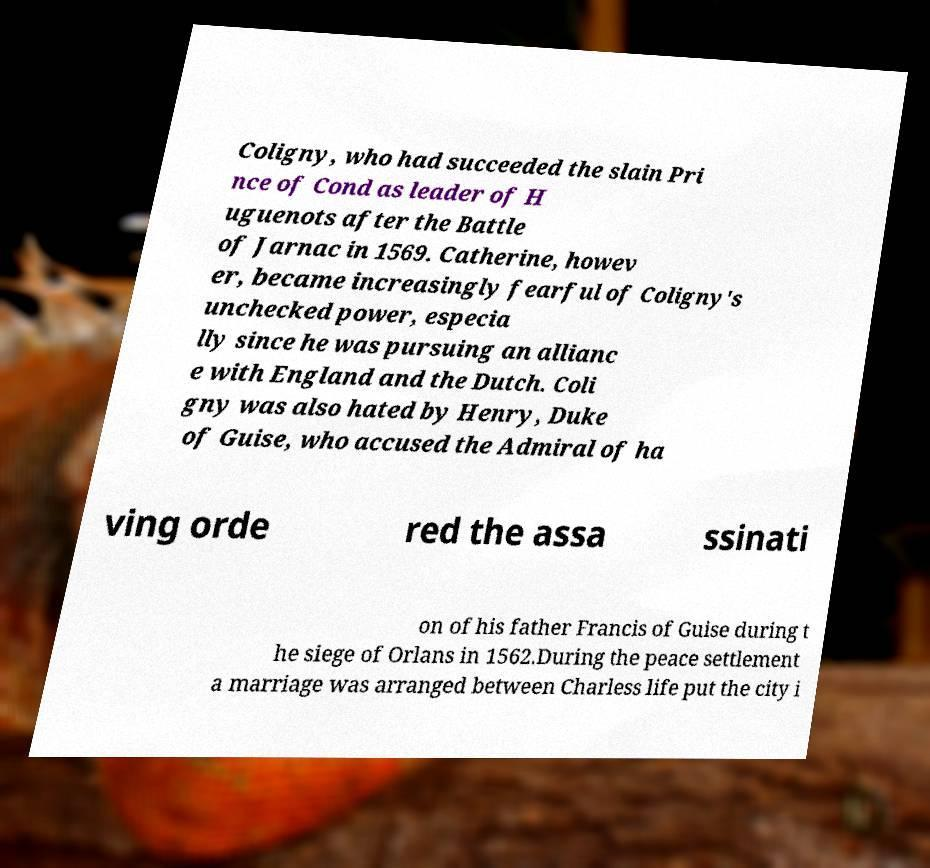Could you extract and type out the text from this image? Coligny, who had succeeded the slain Pri nce of Cond as leader of H uguenots after the Battle of Jarnac in 1569. Catherine, howev er, became increasingly fearful of Coligny's unchecked power, especia lly since he was pursuing an allianc e with England and the Dutch. Coli gny was also hated by Henry, Duke of Guise, who accused the Admiral of ha ving orde red the assa ssinati on of his father Francis of Guise during t he siege of Orlans in 1562.During the peace settlement a marriage was arranged between Charless life put the city i 